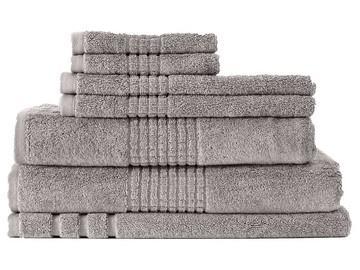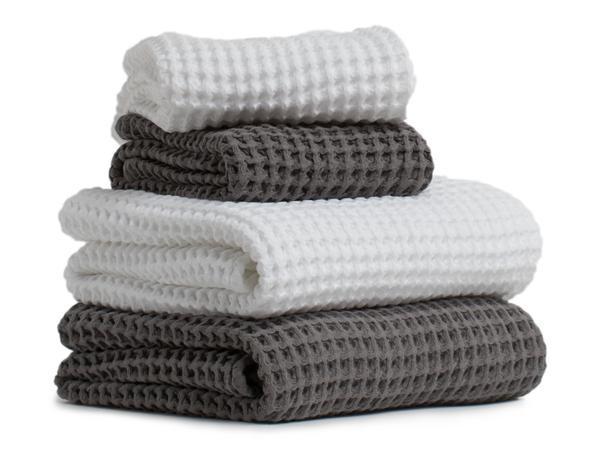The first image is the image on the left, the second image is the image on the right. Given the left and right images, does the statement "The left and right image contains a total of nine towels." hold true? Answer yes or no. No. The first image is the image on the left, the second image is the image on the right. Assess this claim about the two images: "There are more items in the left image than in the right image.". Correct or not? Answer yes or no. Yes. 